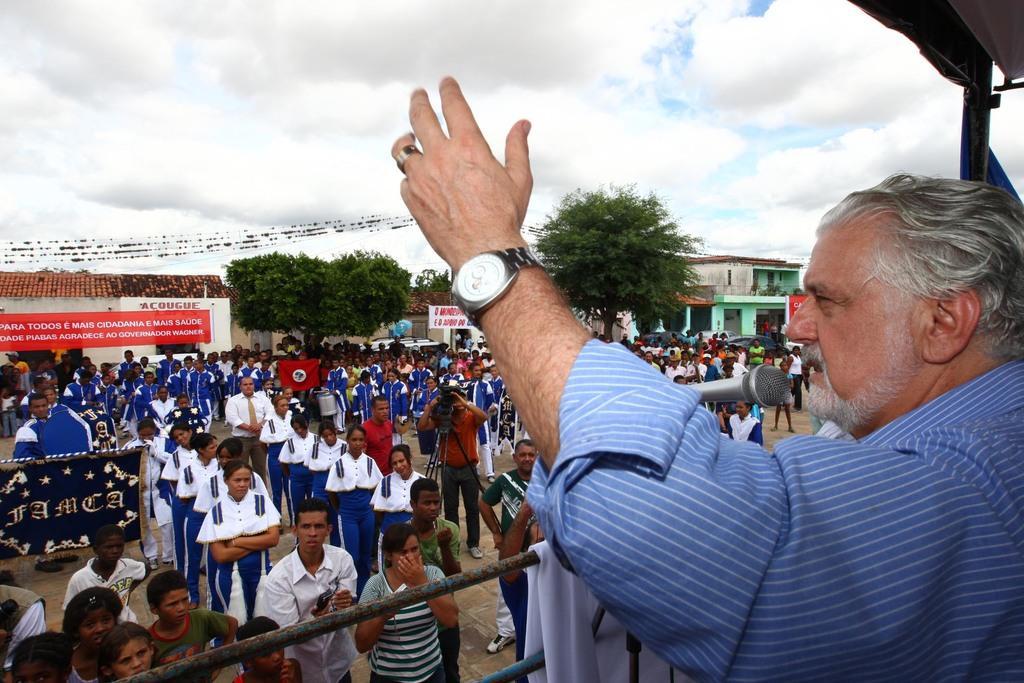Can you describe this image briefly? On the right side there is a person wearing watch is speaking. In front of him there is a mic. Also there are rods. On that there is a white cloth. There are many people standing. One person is holding a camera on a stand. In the back there are many buildings, trees and sky with clouds. 